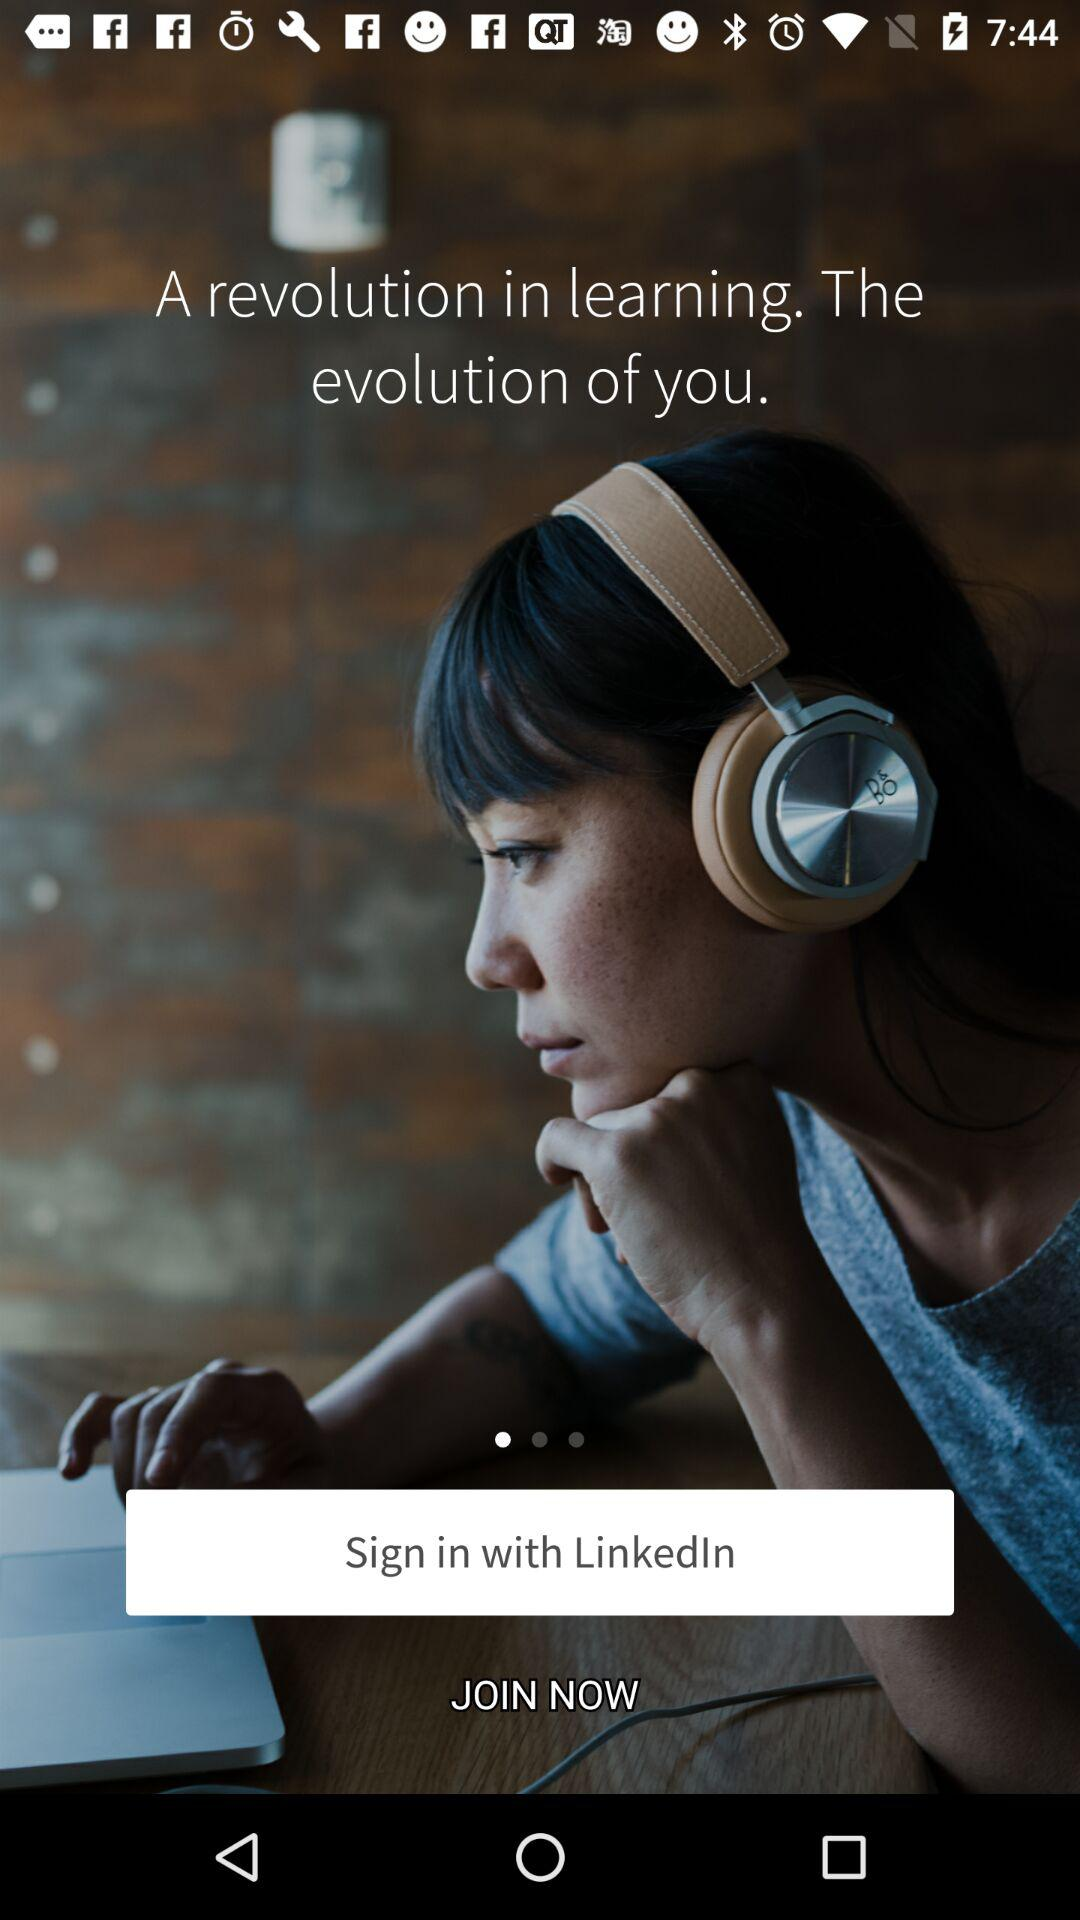Through what application can we sign in with? The application is "LinkedIn". 